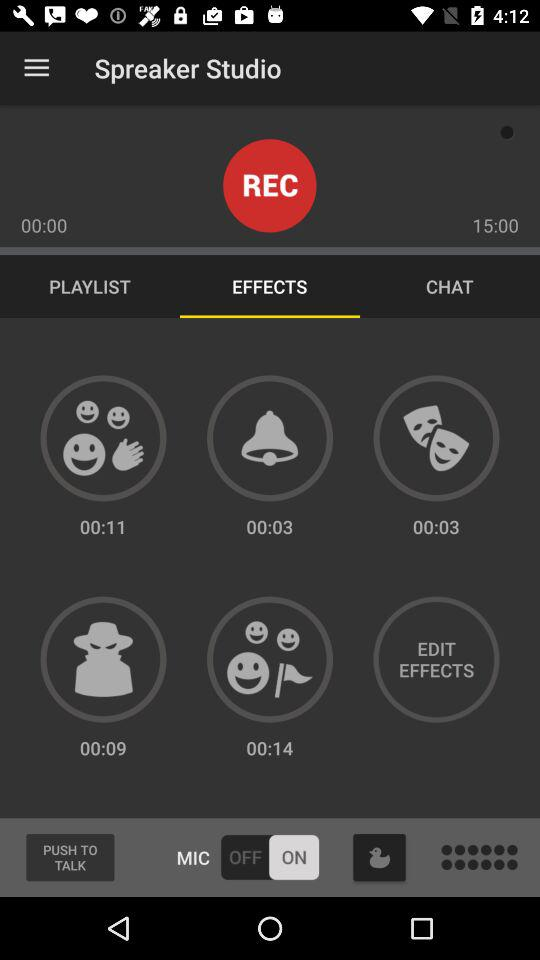Which tab has been selected? The tab that has been selected is "EFFECTS". 